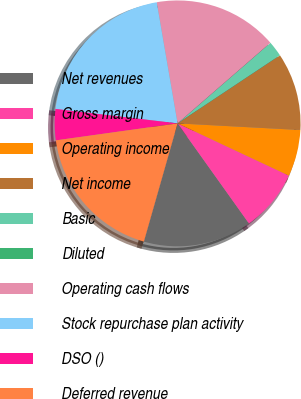Convert chart. <chart><loc_0><loc_0><loc_500><loc_500><pie_chart><fcel>Net revenues<fcel>Gross margin<fcel>Operating income<fcel>Net income<fcel>Basic<fcel>Diluted<fcel>Operating cash flows<fcel>Stock repurchase plan activity<fcel>DSO ()<fcel>Deferred revenue<nl><fcel>14.28%<fcel>8.16%<fcel>6.12%<fcel>10.2%<fcel>2.04%<fcel>0.0%<fcel>16.33%<fcel>20.41%<fcel>4.08%<fcel>18.37%<nl></chart> 